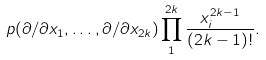<formula> <loc_0><loc_0><loc_500><loc_500>p ( \partial / \partial x _ { 1 } , \dots , \partial / \partial x _ { 2 k } ) \prod _ { 1 } ^ { 2 k } \frac { x _ { i } ^ { 2 k - 1 } } { ( 2 k - 1 ) ! } .</formula> 